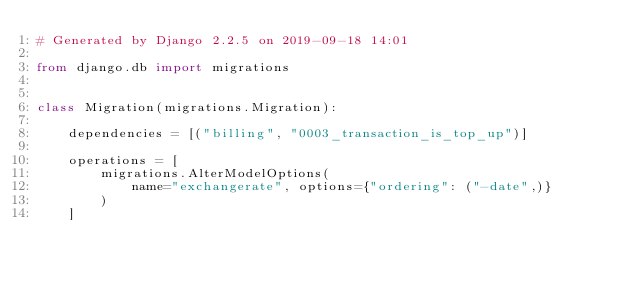Convert code to text. <code><loc_0><loc_0><loc_500><loc_500><_Python_># Generated by Django 2.2.5 on 2019-09-18 14:01

from django.db import migrations


class Migration(migrations.Migration):

    dependencies = [("billing", "0003_transaction_is_top_up")]

    operations = [
        migrations.AlterModelOptions(
            name="exchangerate", options={"ordering": ("-date",)}
        )
    ]
</code> 